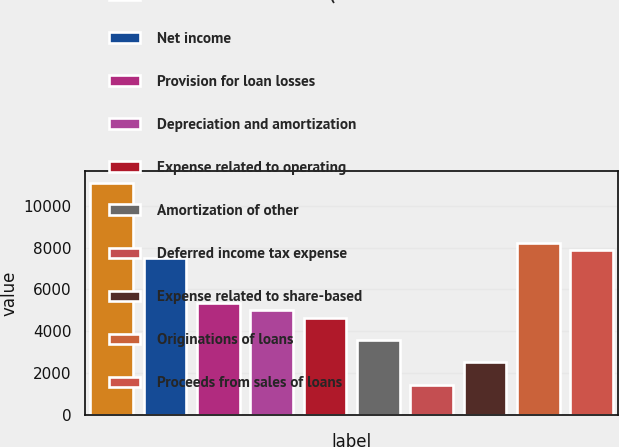<chart> <loc_0><loc_0><loc_500><loc_500><bar_chart><fcel>Years ended December 31 (in<fcel>Net income<fcel>Provision for loan losses<fcel>Depreciation and amortization<fcel>Expense related to operating<fcel>Amortization of other<fcel>Deferred income tax expense<fcel>Expense related to share-based<fcel>Originations of loans<fcel>Proceeds from sales of loans<nl><fcel>11099.5<fcel>7519.23<fcel>5371.05<fcel>5013.02<fcel>4654.99<fcel>3580.9<fcel>1432.72<fcel>2506.81<fcel>8235.29<fcel>7877.26<nl></chart> 